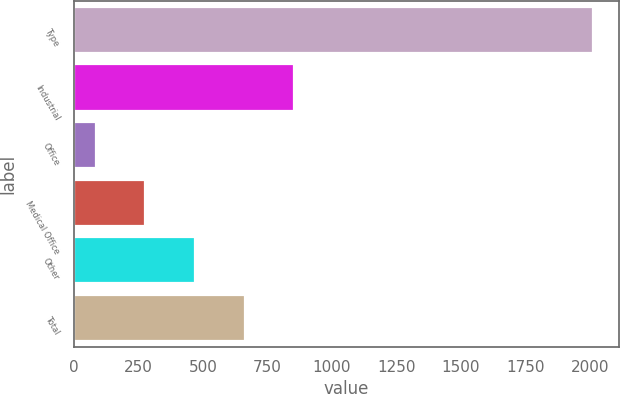Convert chart. <chart><loc_0><loc_0><loc_500><loc_500><bar_chart><fcel>Type<fcel>Industrial<fcel>Office<fcel>Medical Office<fcel>Other<fcel>Total<nl><fcel>2011<fcel>854.5<fcel>83.5<fcel>276.25<fcel>469<fcel>661.75<nl></chart> 